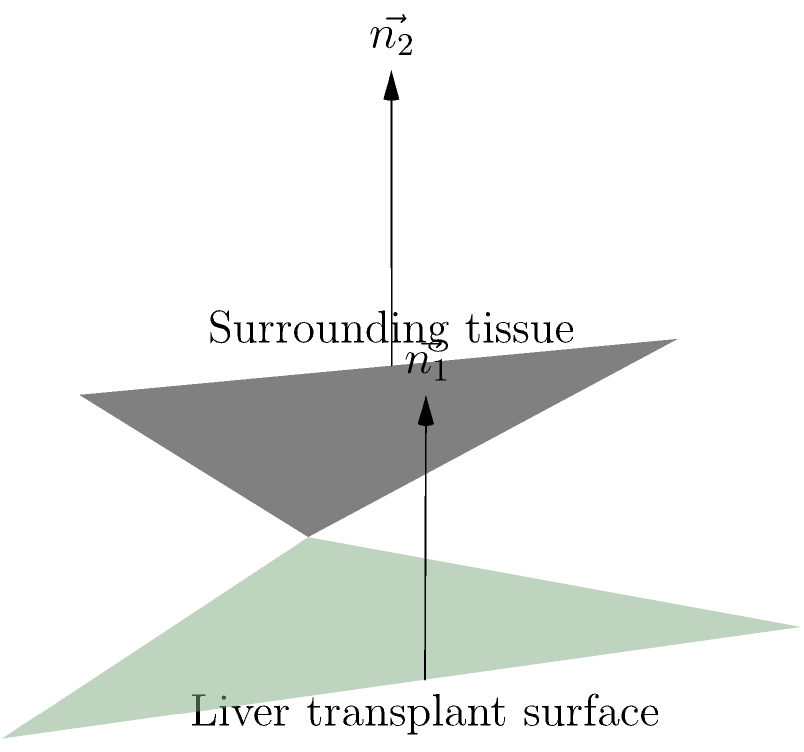In a liver transplant procedure, two planes represent the surface of the liver transplant and the surrounding tissue. The normal vector to the liver transplant surface is $\vec{n_1} = (0, 0, 1)$, and the normal vector to the surrounding tissue is $\vec{n_2} = (1, 1, 1)$. Calculate the angle $\theta$ between these two planes. To find the angle between two planes, we can use the dot product formula for the angle between their normal vectors:

1) The formula for the angle between two vectors is:
   $$\cos \theta = \frac{\vec{n_1} \cdot \vec{n_2}}{|\vec{n_1}||\vec{n_2}|}$$

2) Calculate the dot product $\vec{n_1} \cdot \vec{n_2}$:
   $\vec{n_1} \cdot \vec{n_2} = (0)(1) + (0)(1) + (1)(1) = 1$

3) Calculate the magnitudes of the vectors:
   $|\vec{n_1}| = \sqrt{0^2 + 0^2 + 1^2} = 1$
   $|\vec{n_2}| = \sqrt{1^2 + 1^2 + 1^2} = \sqrt{3}$

4) Substitute into the formula:
   $$\cos \theta = \frac{1}{1 \cdot \sqrt{3}} = \frac{1}{\sqrt{3}}$$

5) Take the inverse cosine (arccos) of both sides:
   $$\theta = \arccos(\frac{1}{\sqrt{3}})$$

6) Calculate the final result:
   $$\theta \approx 54.74^\circ$$

This angle represents the orientation difference between the liver transplant surface and the surrounding tissue, which is crucial for a successful transplant procedure.
Answer: $54.74^\circ$ 